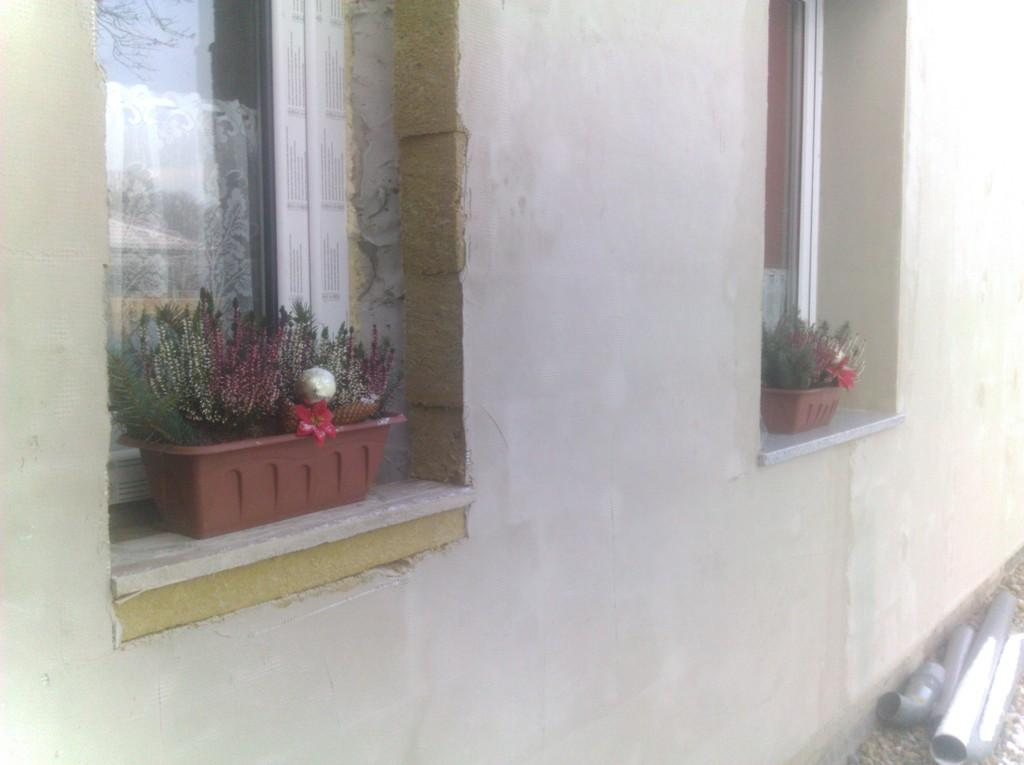What type of structure can be seen in the image? There is a wall in the image. Are there any openings in the wall? Yes, there are windows in the image. What else can be found in the image? There are house plants in the image. What is the purpose of the mountain in the image? There is no mountain present in the image. 